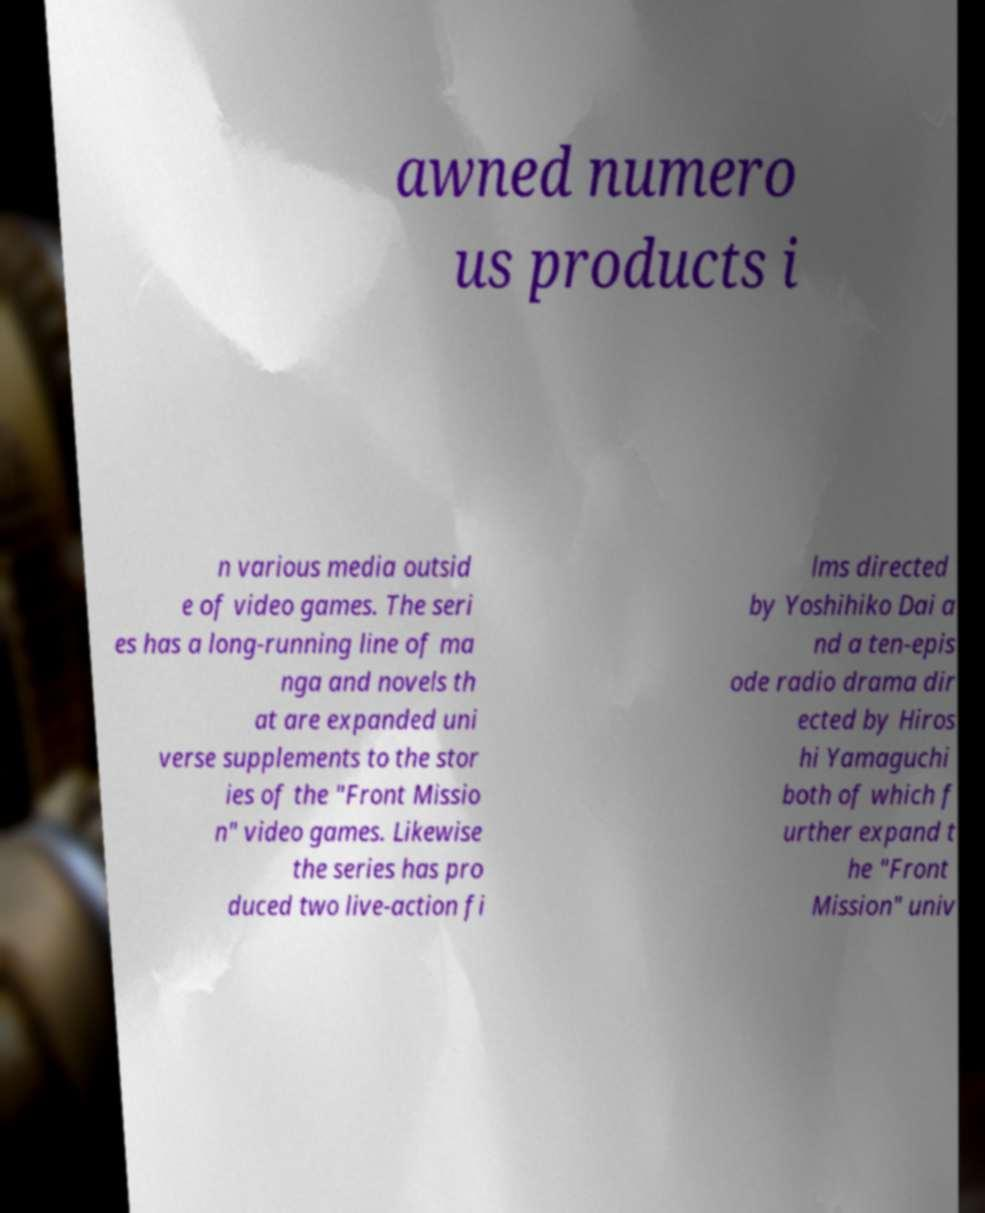There's text embedded in this image that I need extracted. Can you transcribe it verbatim? awned numero us products i n various media outsid e of video games. The seri es has a long-running line of ma nga and novels th at are expanded uni verse supplements to the stor ies of the "Front Missio n" video games. Likewise the series has pro duced two live-action fi lms directed by Yoshihiko Dai a nd a ten-epis ode radio drama dir ected by Hiros hi Yamaguchi both of which f urther expand t he "Front Mission" univ 